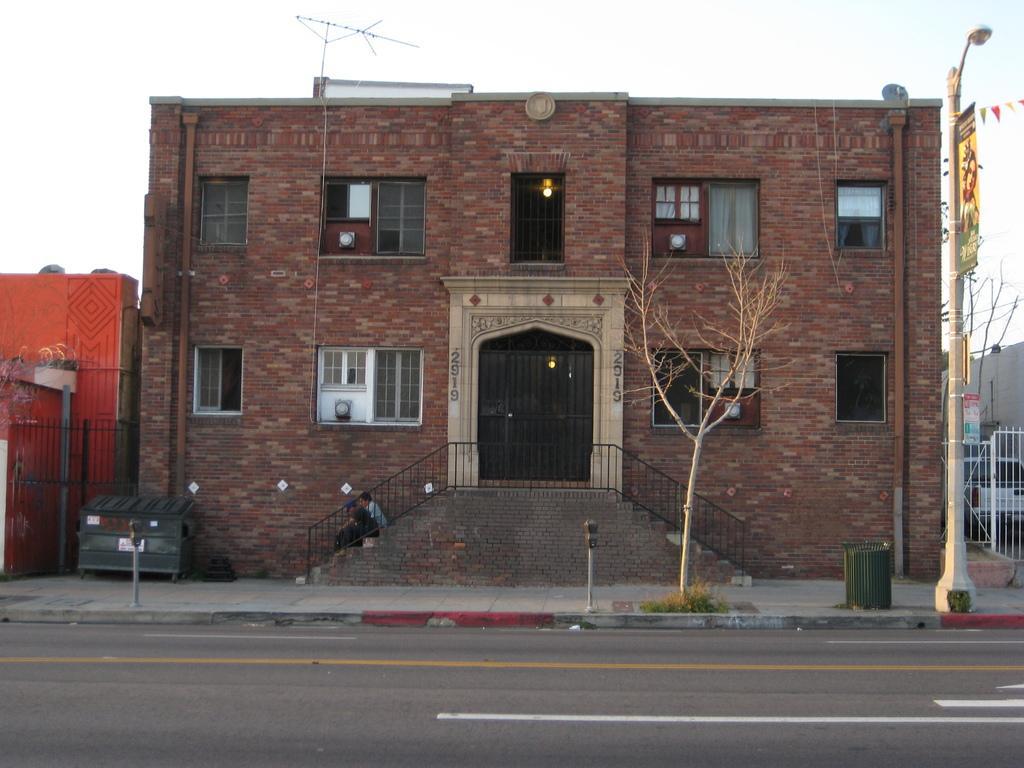Can you describe this image briefly? In the middle of the image we can see a building, staircases and persons sitting on them, pipelines, electric lights and windows. In the background we can see street light, street pole, road and sky. 